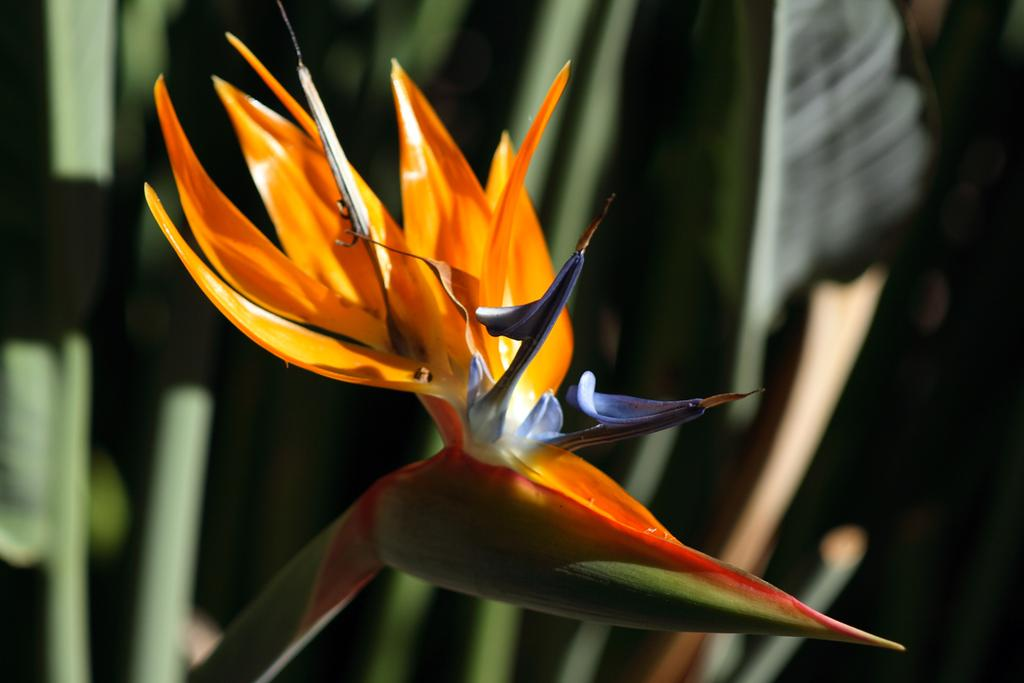What is the main subject of the image? There is a flower in the image. Can you describe the colors of the flower? The flower has orange, purple, and white colors. What part of the flower is visible besides the petals? The stem of the flower is visible. How would you describe the background of the image? The background of the image is blurred. Are there any giants visible in the image? No, there are no giants present in the image. Can you tell me where the nearest shop is located in the image? There is no shop present in the image; it only features a flower. 